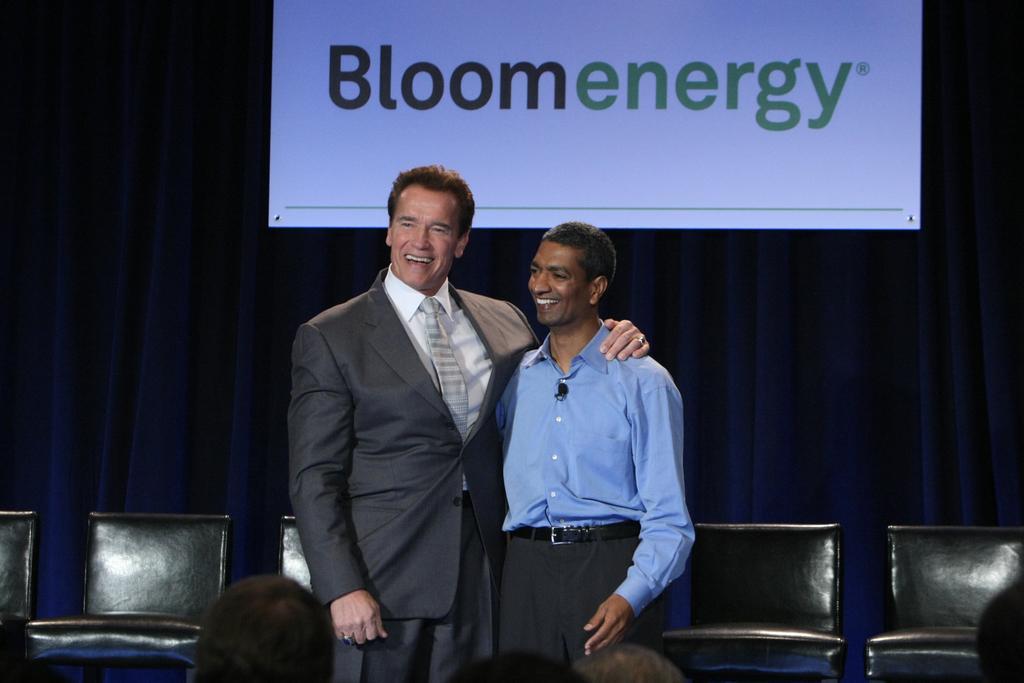Describe this image in one or two sentences. In this picture we can see two persons standing on the floor. These are the chairs. On the background there is a screen. And this is the curtain. 